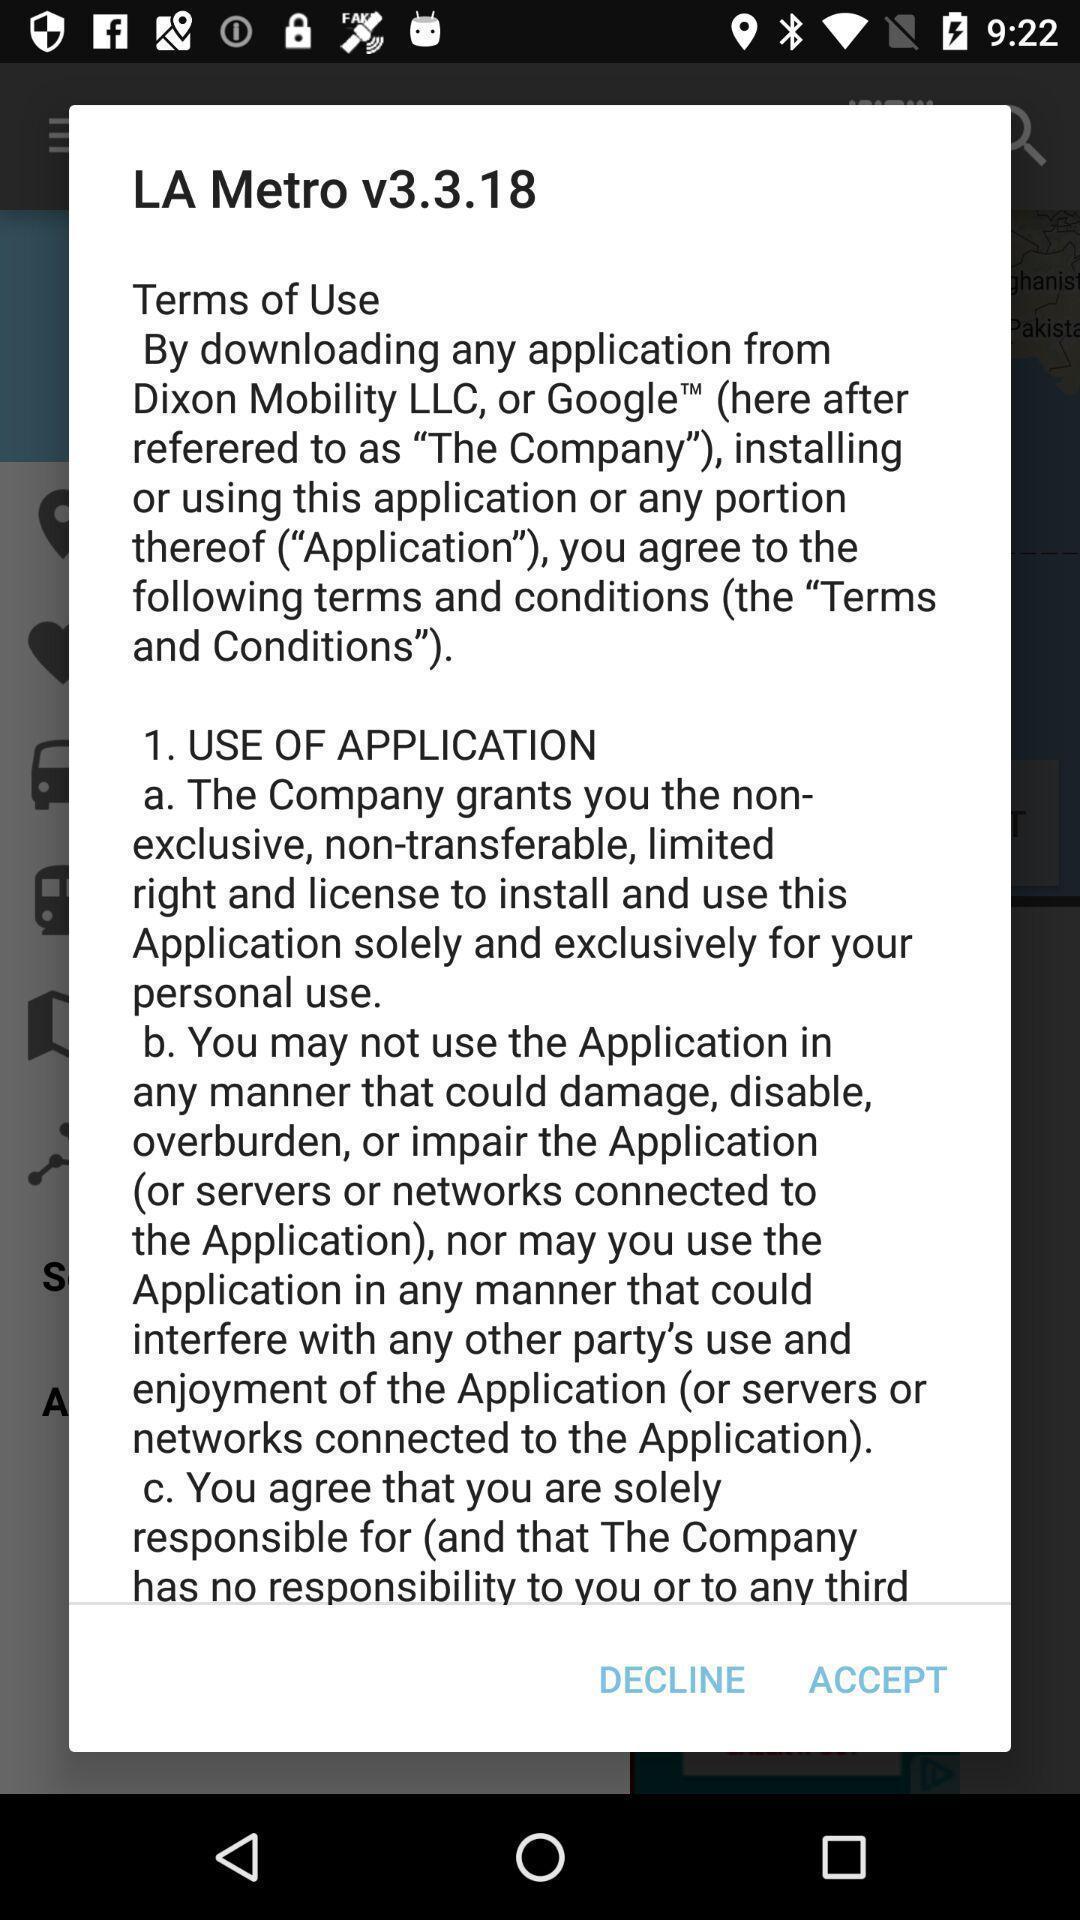What details can you identify in this image? Terms and conditions page of a navigation application. 